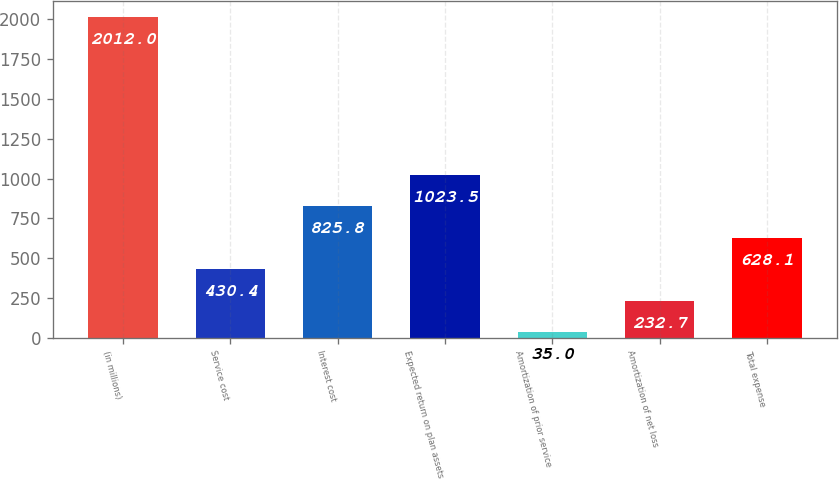Convert chart. <chart><loc_0><loc_0><loc_500><loc_500><bar_chart><fcel>(in millions)<fcel>Service cost<fcel>Interest cost<fcel>Expected return on plan assets<fcel>Amortization of prior service<fcel>Amortization of net loss<fcel>Total expense<nl><fcel>2012<fcel>430.4<fcel>825.8<fcel>1023.5<fcel>35<fcel>232.7<fcel>628.1<nl></chart> 